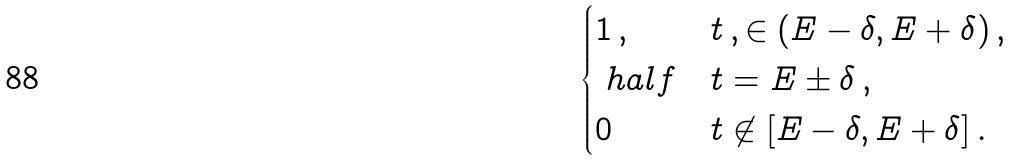Convert formula to latex. <formula><loc_0><loc_0><loc_500><loc_500>\begin{cases} 1 \, , & t \, , \in ( E - \delta , E + \delta ) \, , \\ \ h a l f & t = E \pm \delta \, , \\ 0 & t \not \in [ E - \delta , E + \delta ] \, . \end{cases}</formula> 